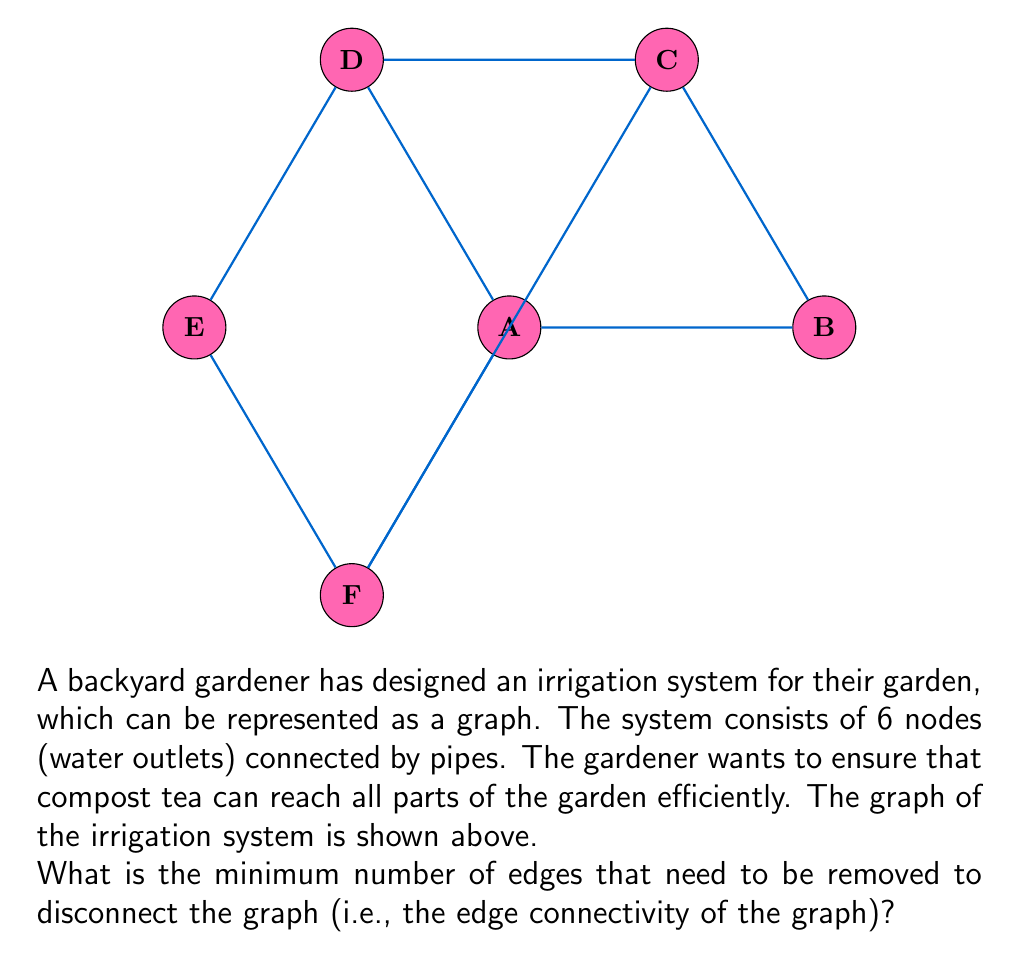Can you answer this question? To find the edge connectivity of the graph, we need to determine the minimum number of edges whose removal would disconnect the graph. Let's approach this step-by-step:

1) First, we need to understand what edge connectivity means. The edge connectivity of a graph is the minimum number of edges that need to be removed to disconnect the graph.

2) We can see that the graph is connected, as there is a path between any two vertices.

3) To disconnect the graph, we need to isolate at least one vertex from the rest of the graph.

4) Let's consider each vertex:
   - Vertex A is connected to 3 other vertices (B, D, F)
   - Vertex B is connected to 2 other vertices (A, C)
   - Vertex C is connected to 3 other vertices (B, D, F)
   - Vertex D is connected to 3 other vertices (A, C, E)
   - Vertex E is connected to 2 other vertices (D, F)
   - Vertex F is connected to 3 other vertices (A, C, E)

5) The vertex with the least number of connections (degree) is 2 (vertices B and E).

6) This means that to isolate either B or E, we need to remove 2 edges.

7) We can verify that removing any single edge will not disconnect the graph, as there are alternative paths between all vertices.

8) Therefore, the minimum number of edges that need to be removed to disconnect the graph is 2.

In graph theory terms, we say that the edge connectivity of this graph is 2.
Answer: 2 